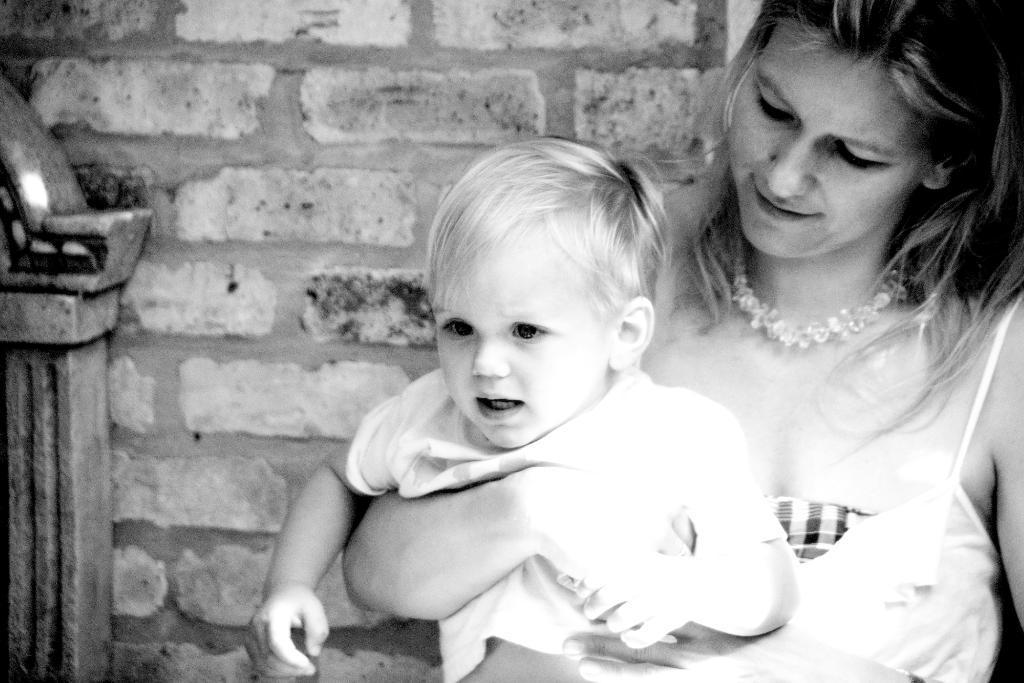Describe this image in one or two sentences. This is a black and white image in this image there is one women who is holding one boy, and in the background there is wall. 